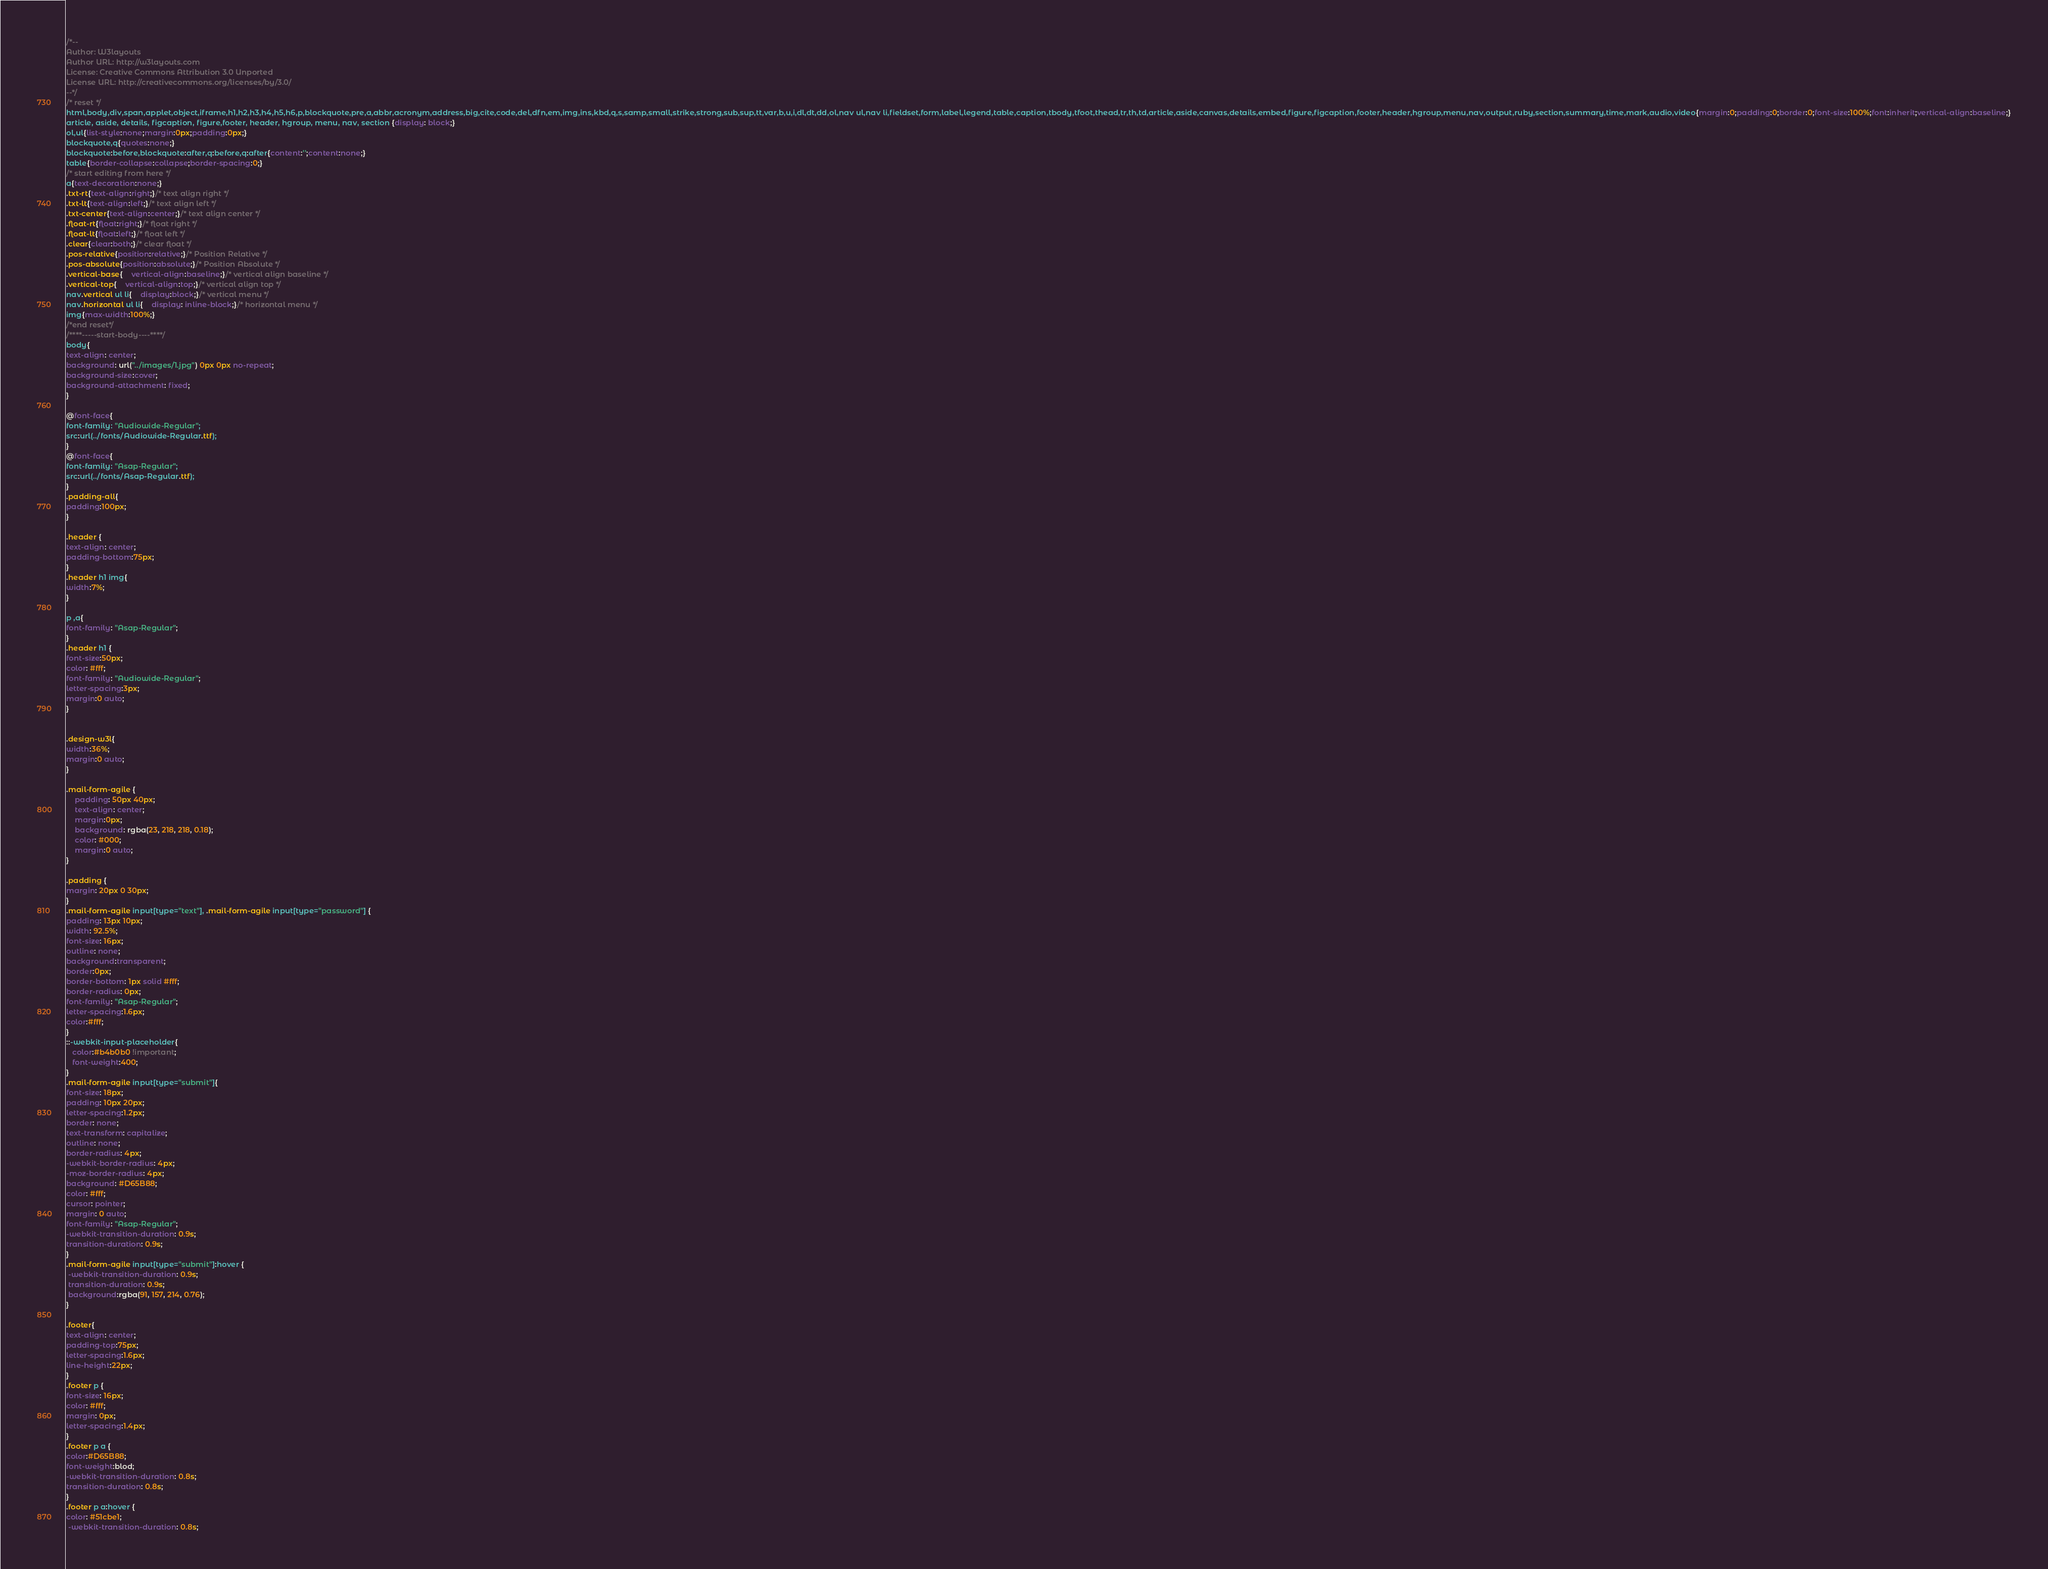Convert code to text. <code><loc_0><loc_0><loc_500><loc_500><_CSS_>/*--
Author: W3layouts
Author URL: http://w3layouts.com
License: Creative Commons Attribution 3.0 Unported
License URL: http://creativecommons.org/licenses/by/3.0/
--*/
/* reset */
html,body,div,span,applet,object,iframe,h1,h2,h3,h4,h5,h6,p,blockquote,pre,a,abbr,acronym,address,big,cite,code,del,dfn,em,img,ins,kbd,q,s,samp,small,strike,strong,sub,sup,tt,var,b,u,i,dl,dt,dd,ol,nav ul,nav li,fieldset,form,label,legend,table,caption,tbody,tfoot,thead,tr,th,td,article,aside,canvas,details,embed,figure,figcaption,footer,header,hgroup,menu,nav,output,ruby,section,summary,time,mark,audio,video{margin:0;padding:0;border:0;font-size:100%;font:inherit;vertical-align:baseline;}
article, aside, details, figcaption, figure,footer, header, hgroup, menu, nav, section {display: block;}
ol,ul{list-style:none;margin:0px;padding:0px;}
blockquote,q{quotes:none;}
blockquote:before,blockquote:after,q:before,q:after{content:'';content:none;}
table{border-collapse:collapse;border-spacing:0;}
/* start editing from here */
a{text-decoration:none;}
.txt-rt{text-align:right;}/* text align right */
.txt-lt{text-align:left;}/* text align left */
.txt-center{text-align:center;}/* text align center */
.float-rt{float:right;}/* float right */
.float-lt{float:left;}/* float left */
.clear{clear:both;}/* clear float */
.pos-relative{position:relative;}/* Position Relative */
.pos-absolute{position:absolute;}/* Position Absolute */
.vertical-base{	vertical-align:baseline;}/* vertical align baseline */
.vertical-top{	vertical-align:top;}/* vertical align top */
nav.vertical ul li{	display:block;}/* vertical menu */
nav.horizontal ul li{	display: inline-block;}/* horizontal menu */
img{max-width:100%;}
/*end reset*/
/****-----start-body----****/
body{
text-align: center;
background: url("../images/1.jpg") 0px 0px no-repeat;
background-size:cover;
background-attachment: fixed;
}

@font-face{
font-family: "Audiowide-Regular";
src:url(../fonts/Audiowide-Regular.ttf);
}
@font-face{
font-family: "Asap-Regular";
src:url(../fonts/Asap-Regular.ttf);
}
.padding-all{
padding:100px;
}

.header {
text-align: center;
padding-bottom:75px;
}
.header h1 img{
width:7%;
}

p ,a{
font-family: "Asap-Regular";
}
.header h1 {
font-size:50px;
color: #fff;
font-family: "Audiowide-Regular";
letter-spacing:3px;
margin:0 auto;
}


.design-w3l{
width:36%;
margin:0 auto;
}

.mail-form-agile {
    padding: 50px 40px;
    text-align: center;
    margin:0px;
    background: rgba(23, 218, 218, 0.18);
    color: #000;
	margin:0 auto;
}

.padding {
margin: 20px 0 30px;
}
.mail-form-agile input[type="text"], .mail-form-agile input[type="password"] {
padding: 13px 10px;
width: 92.5%;
font-size: 16px;
outline: none;
background:transparent;
border:0px;
border-bottom: 1px solid #fff;
border-radius: 0px;
font-family: "Asap-Regular";
letter-spacing:1.6px;
color:#fff;
}
::-webkit-input-placeholder{
   color:#b4b0b0 !important;
   font-weight:400;
}
.mail-form-agile input[type="submit"]{
font-size: 18px;
padding: 10px 20px;
letter-spacing:1.2px;
border: none;
text-transform: capitalize;
outline: none;
border-radius: 4px;
-webkit-border-radius: 4px;
-moz-border-radius: 4px;
background: #D65B88;
color: #fff;
cursor: pointer;
margin: 0 auto;
font-family: "Asap-Regular";
-webkit-transition-duration: 0.9s;
transition-duration: 0.9s;
}
.mail-form-agile input[type="submit"]:hover {
 -webkit-transition-duration: 0.9s;
 transition-duration: 0.9s;
 background:rgba(91, 157, 214, 0.76);
}

.footer{
text-align: center;
padding-top:75px;
letter-spacing:1.6px;
line-height:22px;
}
.footer p {
font-size: 16px;
color: #fff;
margin: 0px;
letter-spacing:1.4px;
}
.footer p a {
color:#D65B88;
font-weight:blod;
-webkit-transition-duration: 0.8s;
transition-duration: 0.8s;
}
.footer p a:hover {
color: #51cbe1;
 -webkit-transition-duration: 0.8s;</code> 